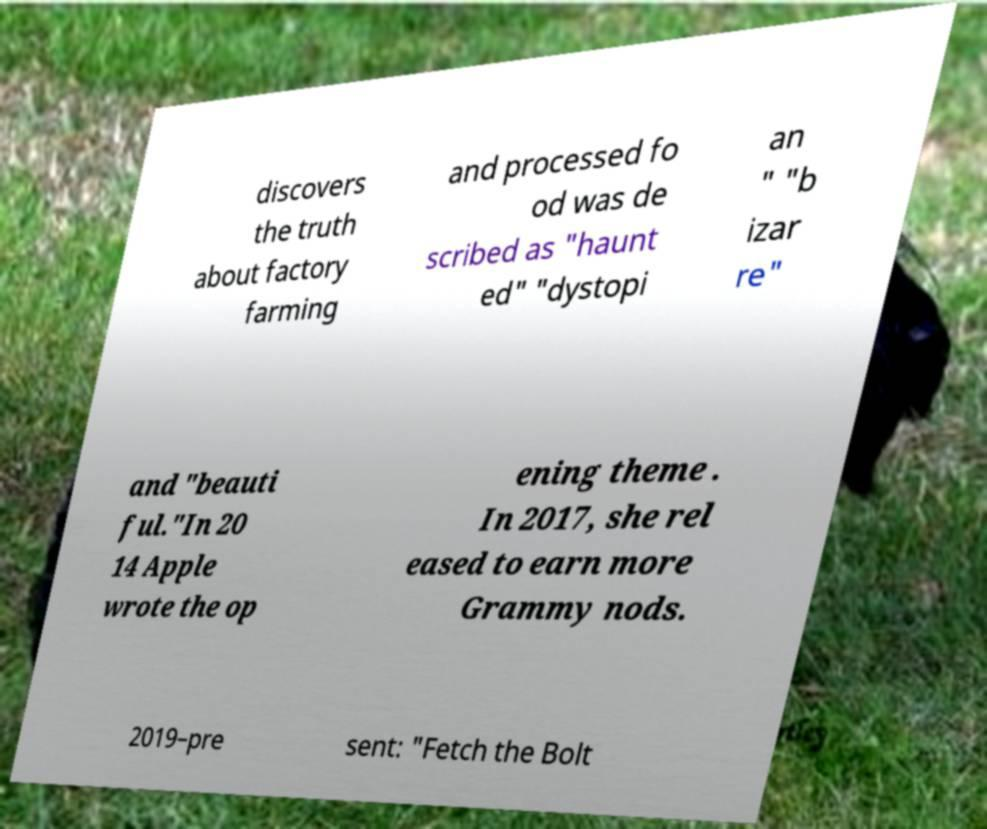For documentation purposes, I need the text within this image transcribed. Could you provide that? discovers the truth about factory farming and processed fo od was de scribed as "haunt ed" "dystopi an " "b izar re" and "beauti ful."In 20 14 Apple wrote the op ening theme . In 2017, she rel eased to earn more Grammy nods. 2019–pre sent: "Fetch the Bolt 